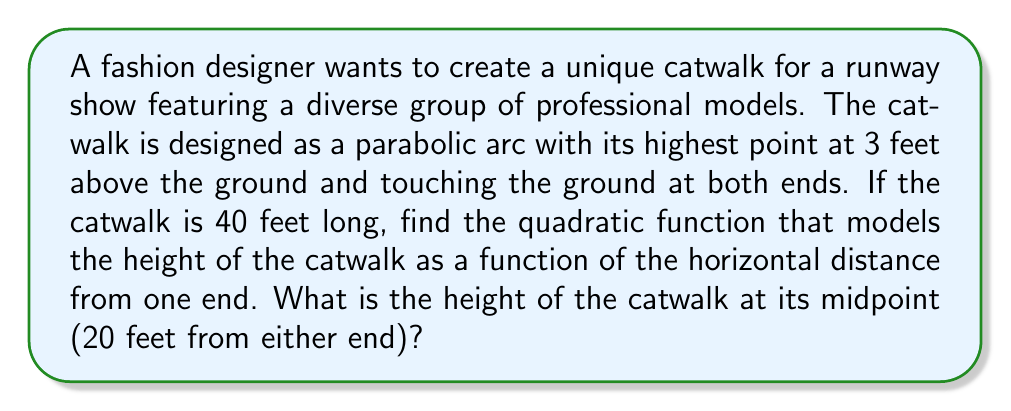Help me with this question. Let's approach this step-by-step:

1) The general form of a quadratic function is $f(x) = ax^2 + bx + c$.

2) We know three points on this parabola:
   - (0, 0): The start of the catwalk
   - (20, 3): The highest point (vertex) at the middle
   - (40, 0): The end of the catwalk

3) Since the parabola is symmetric and the highest point is in the middle, we can simplify our equation to:
   $f(x) = a(x-20)^2 + 3$

4) Now we need to find $a$. We can use the point (0, 0):
   $0 = a(0-20)^2 + 3$
   $0 = 400a + 3$
   $-3 = 400a$
   $a = -\frac{3}{400} = -0.0075$

5) Therefore, our quadratic function is:
   $f(x) = -0.0075(x-20)^2 + 3$

6) To find the height at the midpoint, we simply need to calculate $f(20)$:
   $f(20) = -0.0075(20-20)^2 + 3 = 3$

This confirms that the highest point is indeed 3 feet above the ground.
Answer: $f(x) = -0.0075(x-20)^2 + 3$; Height at midpoint: 3 feet 